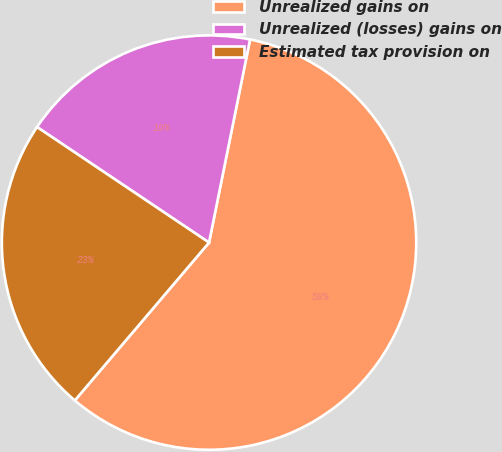<chart> <loc_0><loc_0><loc_500><loc_500><pie_chart><fcel>Unrealized gains on<fcel>Unrealized (losses) gains on<fcel>Estimated tax provision on<nl><fcel>58.05%<fcel>18.76%<fcel>23.2%<nl></chart> 